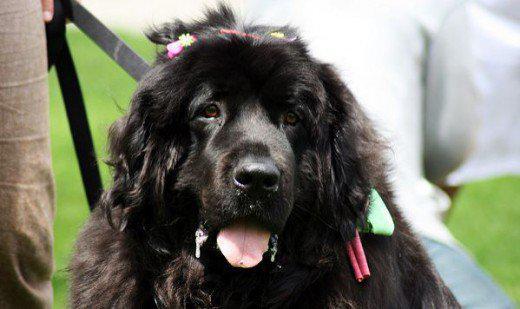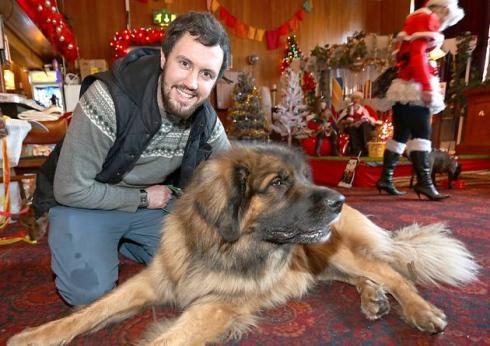The first image is the image on the left, the second image is the image on the right. Assess this claim about the two images: "Santa-themed red and white attire is included in one image with at least one dog.". Correct or not? Answer yes or no. Yes. The first image is the image on the left, the second image is the image on the right. Considering the images on both sides, is "Christmas decorations can be seen in one of the pictures." valid? Answer yes or no. Yes. 